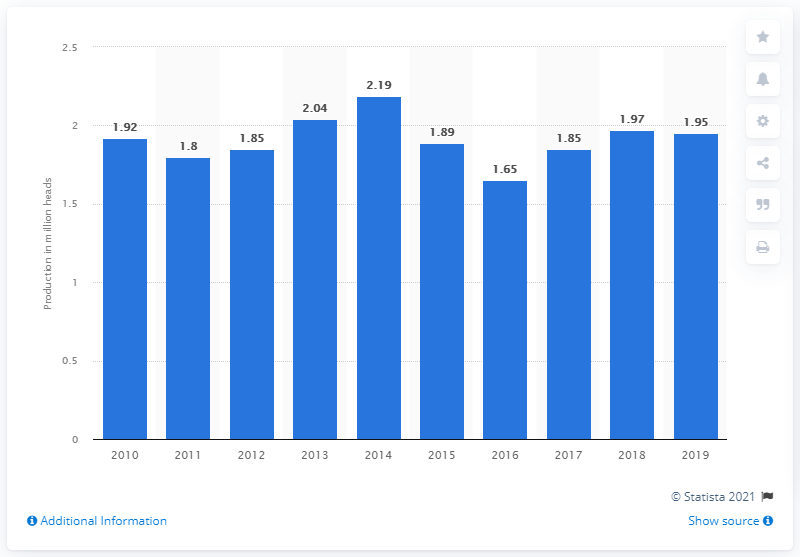List a handful of essential elements in this visual. According to data, Malaysia's pig production reached its highest level in 2014. In 2019, a total of 1.95 million pigs were produced in Malaysia. 